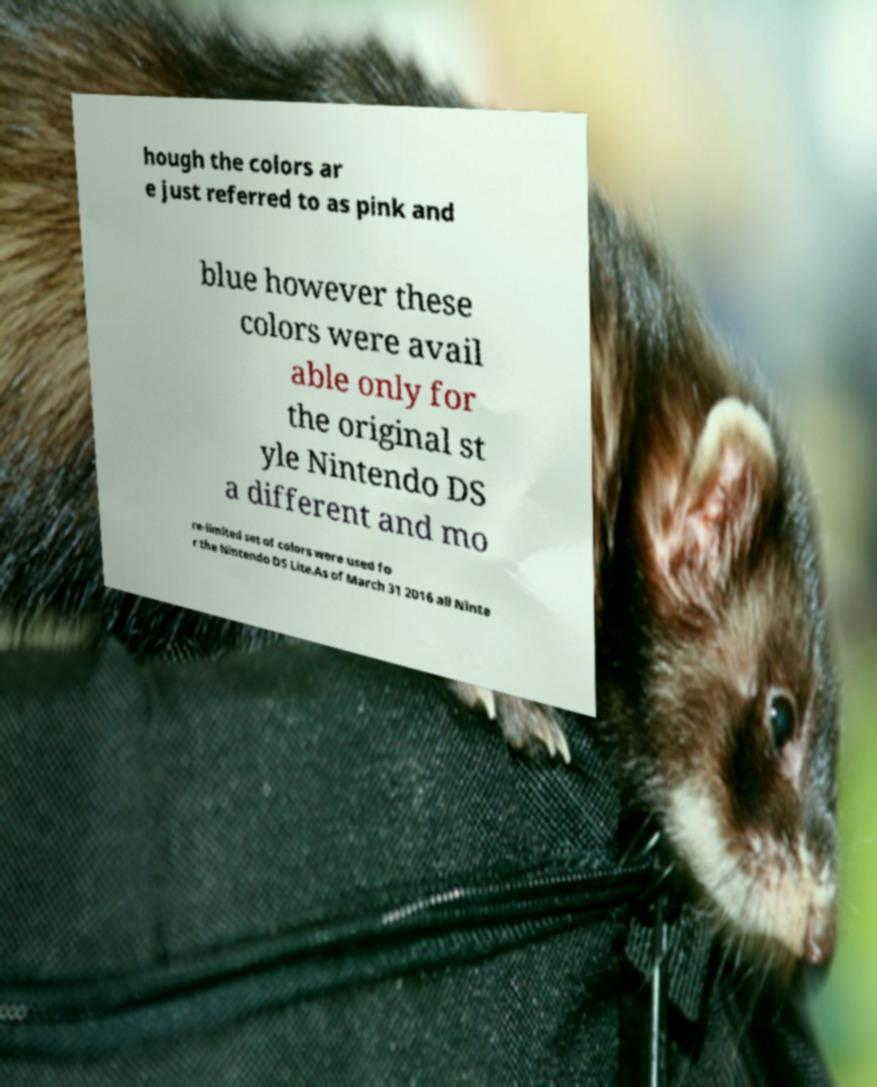Please read and relay the text visible in this image. What does it say? hough the colors ar e just referred to as pink and blue however these colors were avail able only for the original st yle Nintendo DS a different and mo re-limited set of colors were used fo r the Nintendo DS Lite.As of March 31 2016 all Ninte 